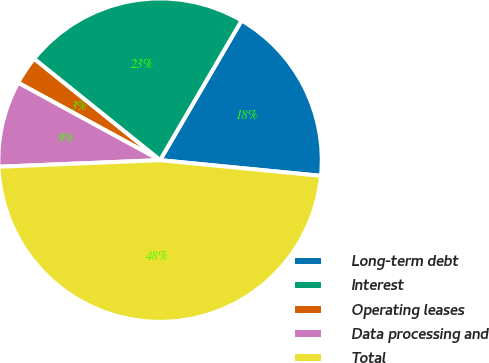Convert chart. <chart><loc_0><loc_0><loc_500><loc_500><pie_chart><fcel>Long-term debt<fcel>Interest<fcel>Operating leases<fcel>Data processing and<fcel>Total<nl><fcel>18.14%<fcel>22.63%<fcel>2.83%<fcel>8.6%<fcel>47.8%<nl></chart> 